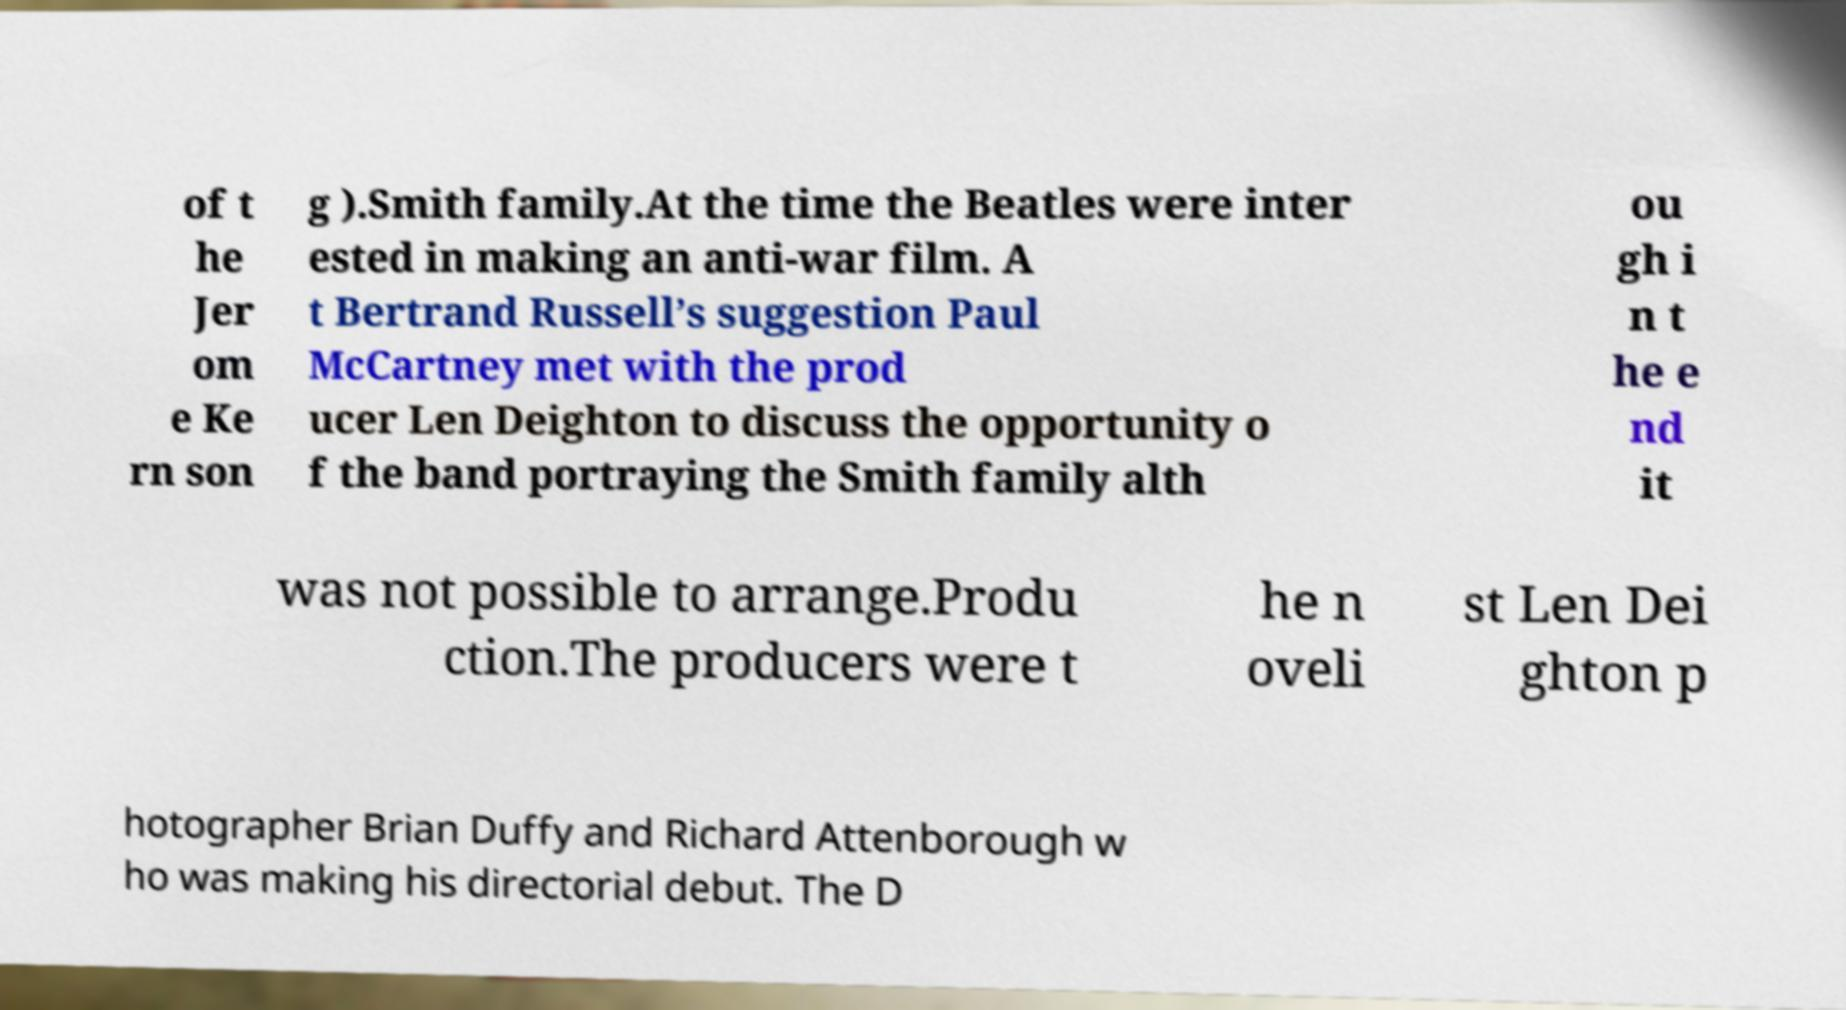For documentation purposes, I need the text within this image transcribed. Could you provide that? of t he Jer om e Ke rn son g ).Smith family.At the time the Beatles were inter ested in making an anti-war film. A t Bertrand Russell’s suggestion Paul McCartney met with the prod ucer Len Deighton to discuss the opportunity o f the band portraying the Smith family alth ou gh i n t he e nd it was not possible to arrange.Produ ction.The producers were t he n oveli st Len Dei ghton p hotographer Brian Duffy and Richard Attenborough w ho was making his directorial debut. The D 